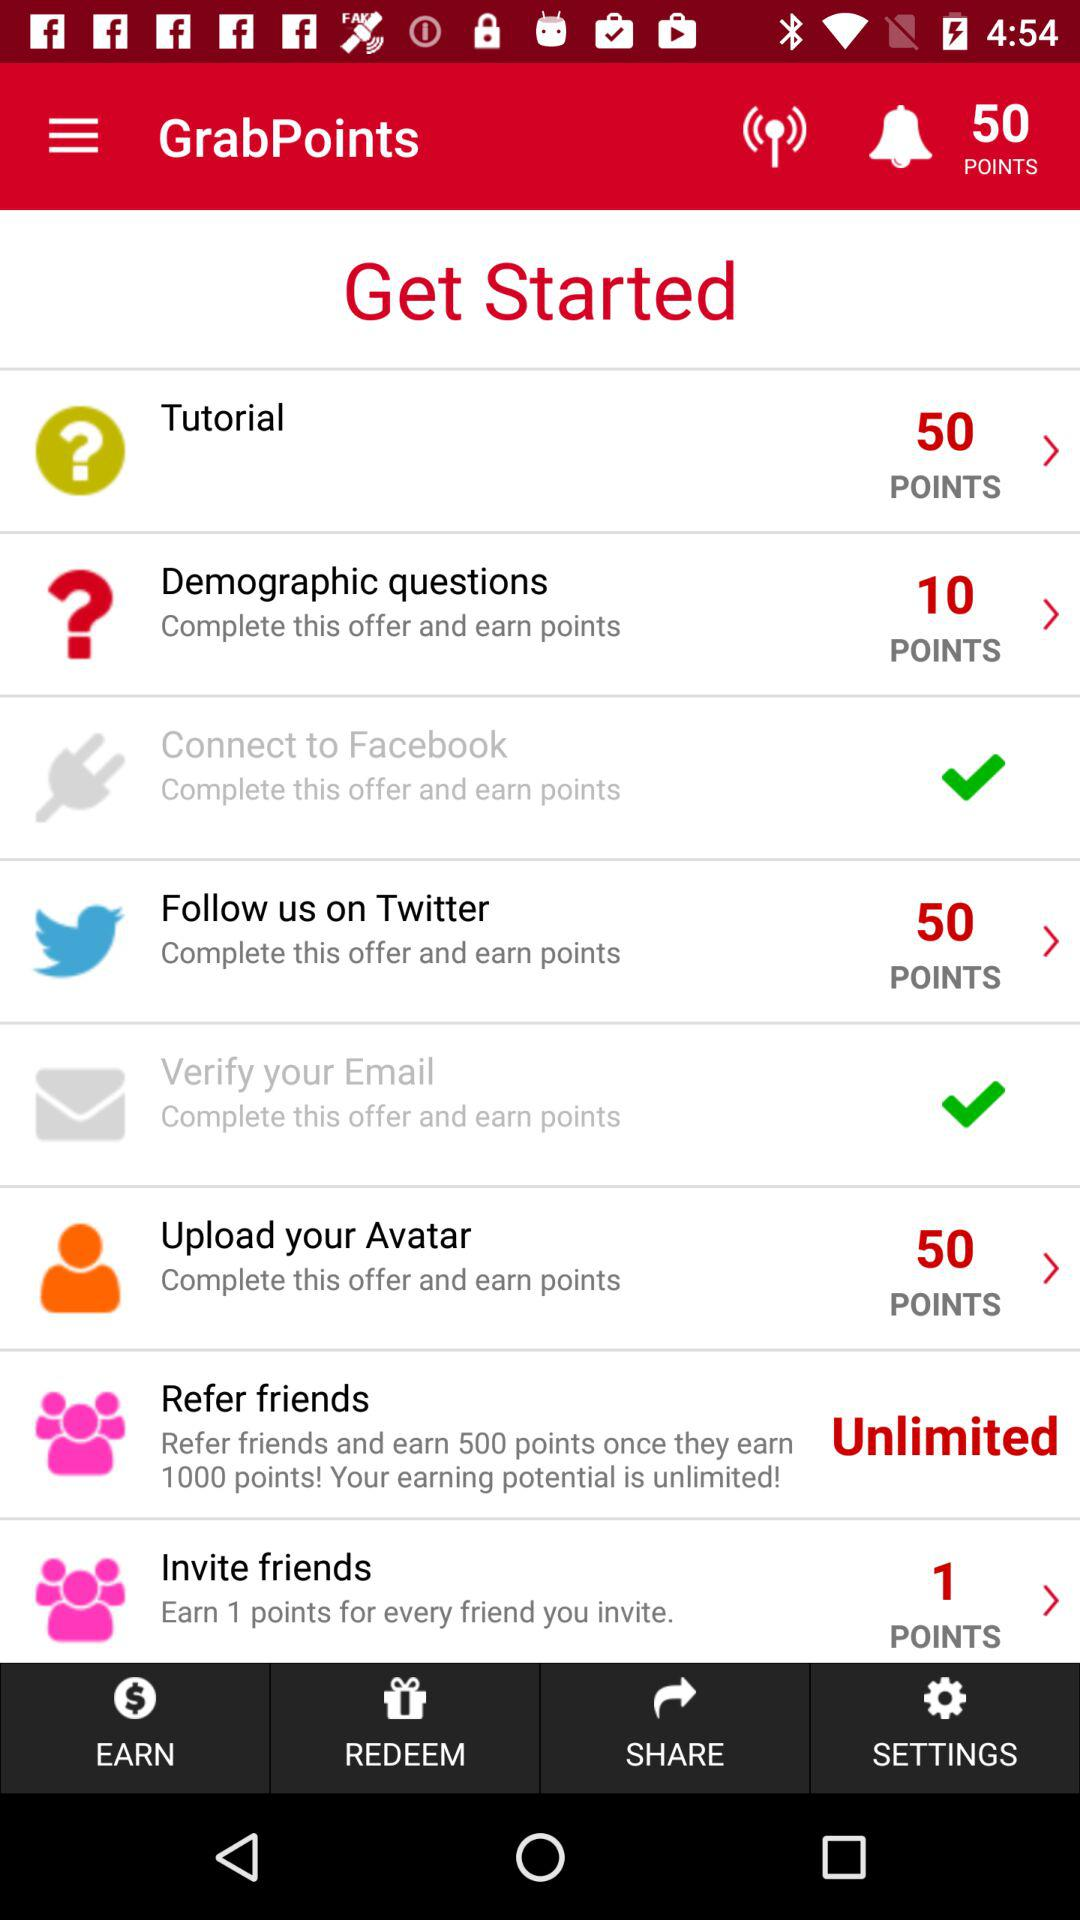How many points do you earn for completing the demographic questions offer?
Answer the question using a single word or phrase. 10 